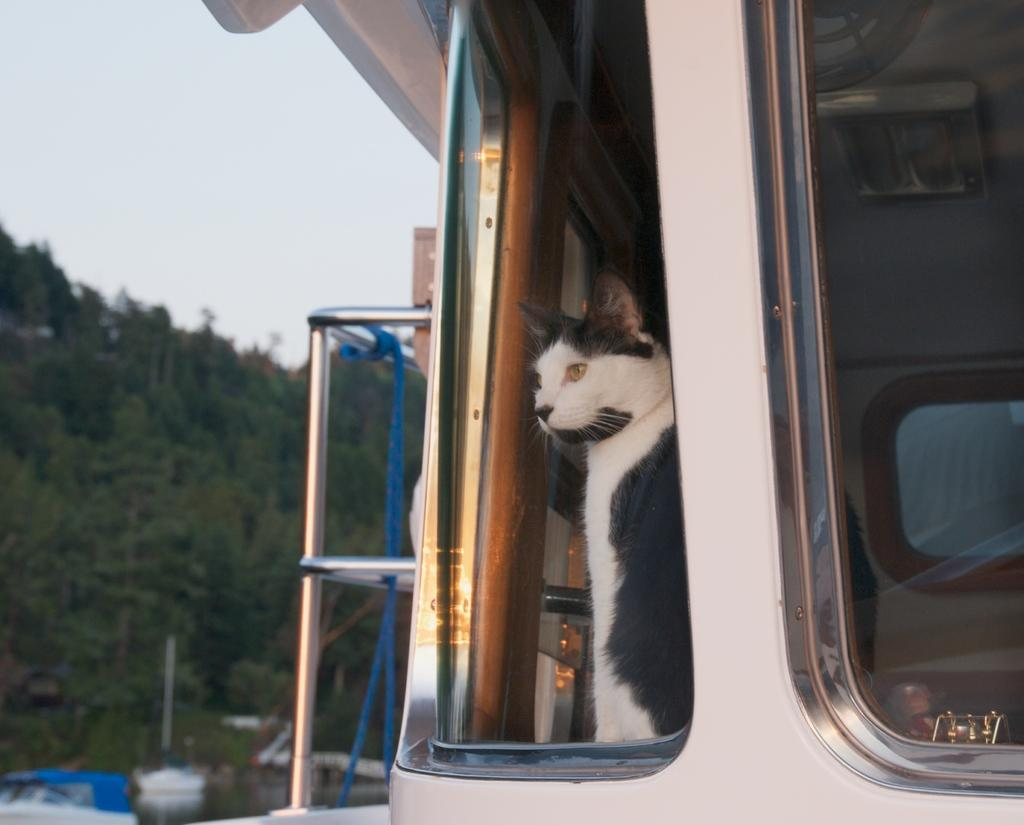Where was the picture taken? The picture was clicked outside. What animal can be seen on the right side of the image? There is a cat on the right side of the image. What type of object is present in the image? There is a vehicle in the image. What material is used for the rods visible in the image? Metal rods are visible in the image. What can be seen in the background of the image? The sky, trees, and other objects are visible in the background of the image. What type of mint is growing near the cat in the image? There is no mint visible in the image; it only features a cat, a vehicle, metal rods, and background elements. What historical event is being commemorated in the image? There is no indication of any historical event being commemorated in the image. 